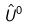<formula> <loc_0><loc_0><loc_500><loc_500>\hat { U } ^ { 0 }</formula> 